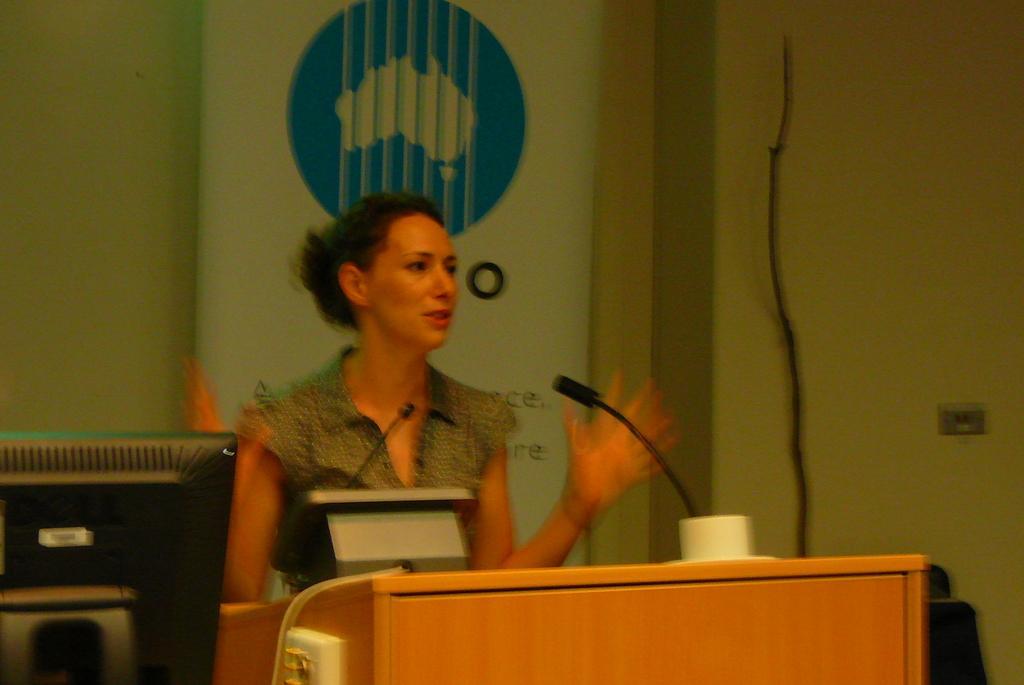Please provide a concise description of this image. In this picture we can see a woman standing at the speech desk and giving a speech. On the left side there is a black computer screen. Behind we can see the banner on the white wall. 